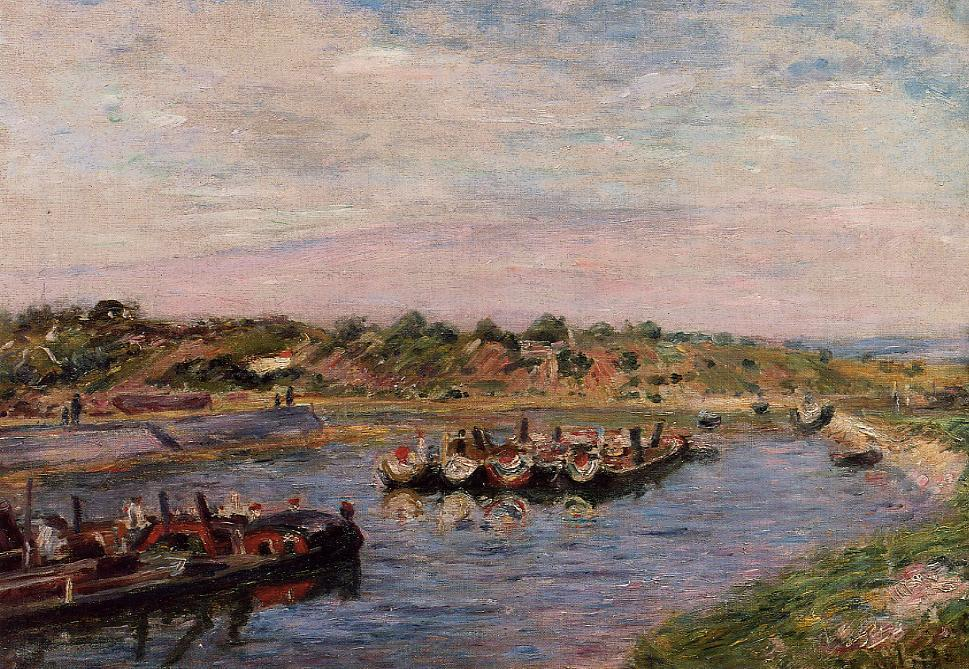Can you describe the techniques used by the artist to create a sense of depth in the painting? The artist employs several notable techniques to create a sense of depth in this painting. One primary method is the use of perspective, with the river narrowing as it moves into the background, effectively drawing the viewer's eye deeper into the scene. This is complemented by the placement of boats at varying distances from the viewer, from the foreground all the way into the background, enhancing the three-dimensionality of the composition.

Additionally, the artist uses atmospheric perspective. The colors of the distant hills and sky are lighter and less saturated compared to those in the foreground, mimicking how objects appear hazier and paler the farther they are from the observer. This gradient in color and detail creates the illusion of depth and distance.

The inclusion of overlapping elements, such as the boats and the people along the riverbanks, further adds to the depth. By positioning these elements at different planes within the composition, the artist provides a layered effect that makes the scene appear more dynamic and expansive. What would the scene look like if it were modernized? Imagine a contemporary version of the sharegpt4v/same scene. In a modernized version of this scene, one might envision some notable changes while preserving the core elements of the river and its banks. The people, instead of wearing traditional attire, might be dressed in modern casual clothing, with some sporting sunglasses, hats, or summer dresses and shorts. You might see modern recreational boats or sleek yachts dotting the river, perhaps with people enjoying water sports or leisure cruises.

The riverbanks could feature modern amenities like cafes, restaurants, and picnic spots, with contemporary outdoor furniture, such as benches and tables with umbrellas. There could be public art installations or sculptures, adding an element of modern cultural expression to the scene. Technology might also be present, with some people seen taking photos or selfies with smartphones, while others could have tablets or e-readers.

In the background, the hills could retain their natural beauty, but you might notice modern houses or buildings with contemporary architecture, potentially including waterfront properties with large glass windows and terraces. The sky might still be a beautiful blue, but you could imagine a more detailed rendering with more precise cloud formations due to the modern advancement in art techniques. 